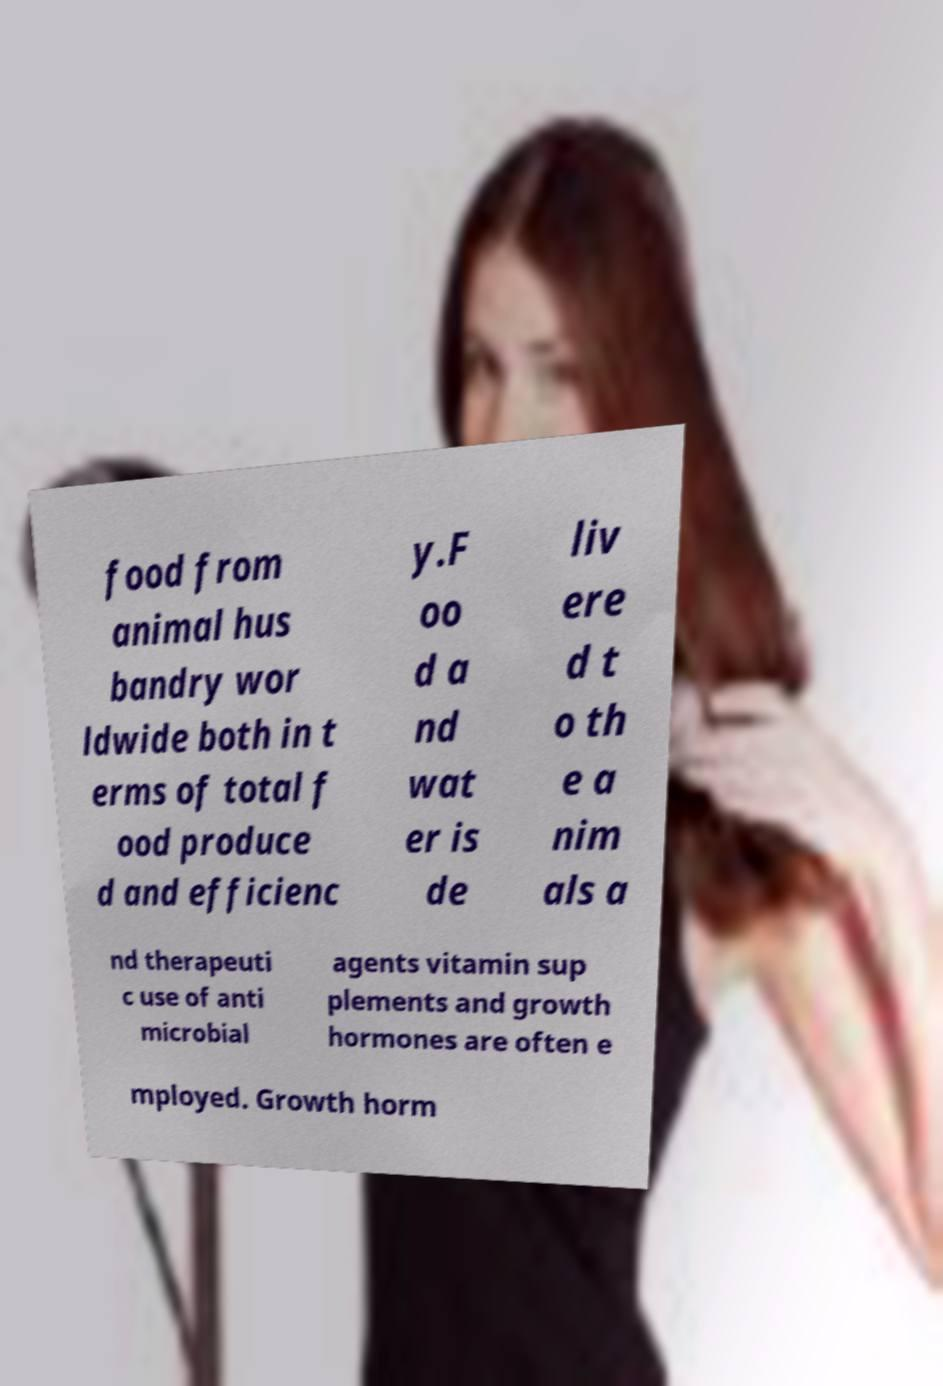Could you extract and type out the text from this image? food from animal hus bandry wor ldwide both in t erms of total f ood produce d and efficienc y.F oo d a nd wat er is de liv ere d t o th e a nim als a nd therapeuti c use of anti microbial agents vitamin sup plements and growth hormones are often e mployed. Growth horm 